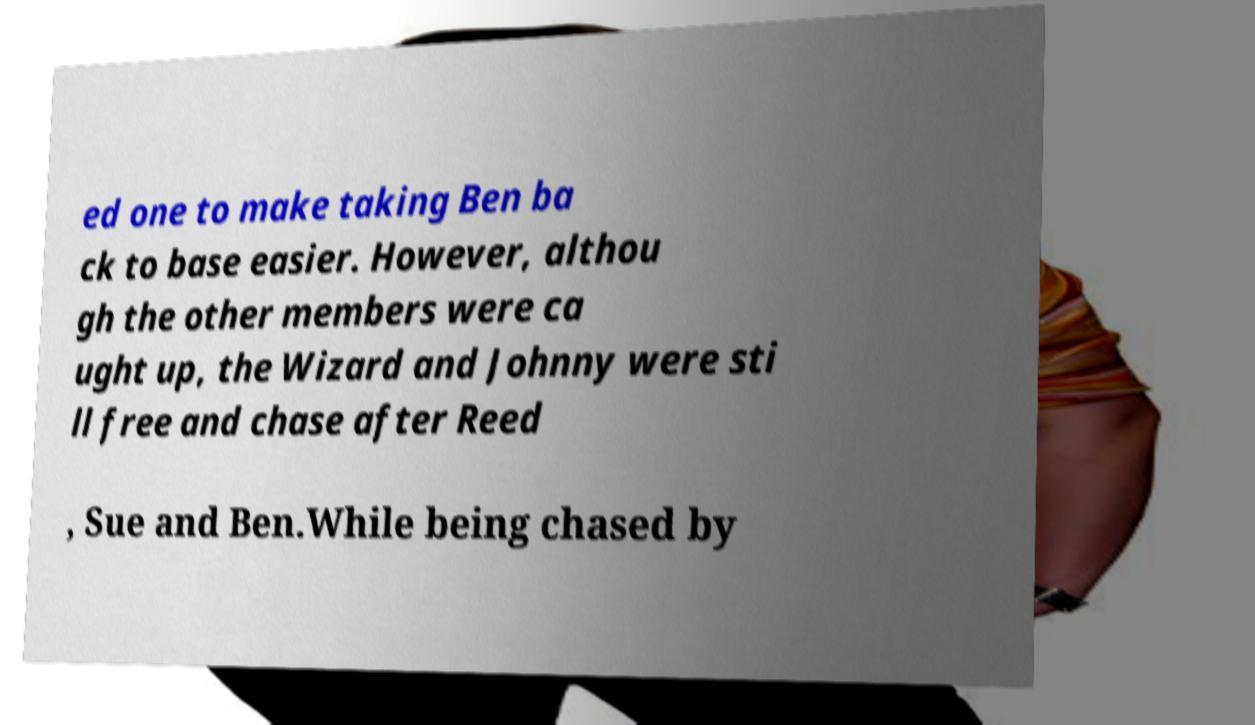I need the written content from this picture converted into text. Can you do that? ed one to make taking Ben ba ck to base easier. However, althou gh the other members were ca ught up, the Wizard and Johnny were sti ll free and chase after Reed , Sue and Ben.While being chased by 